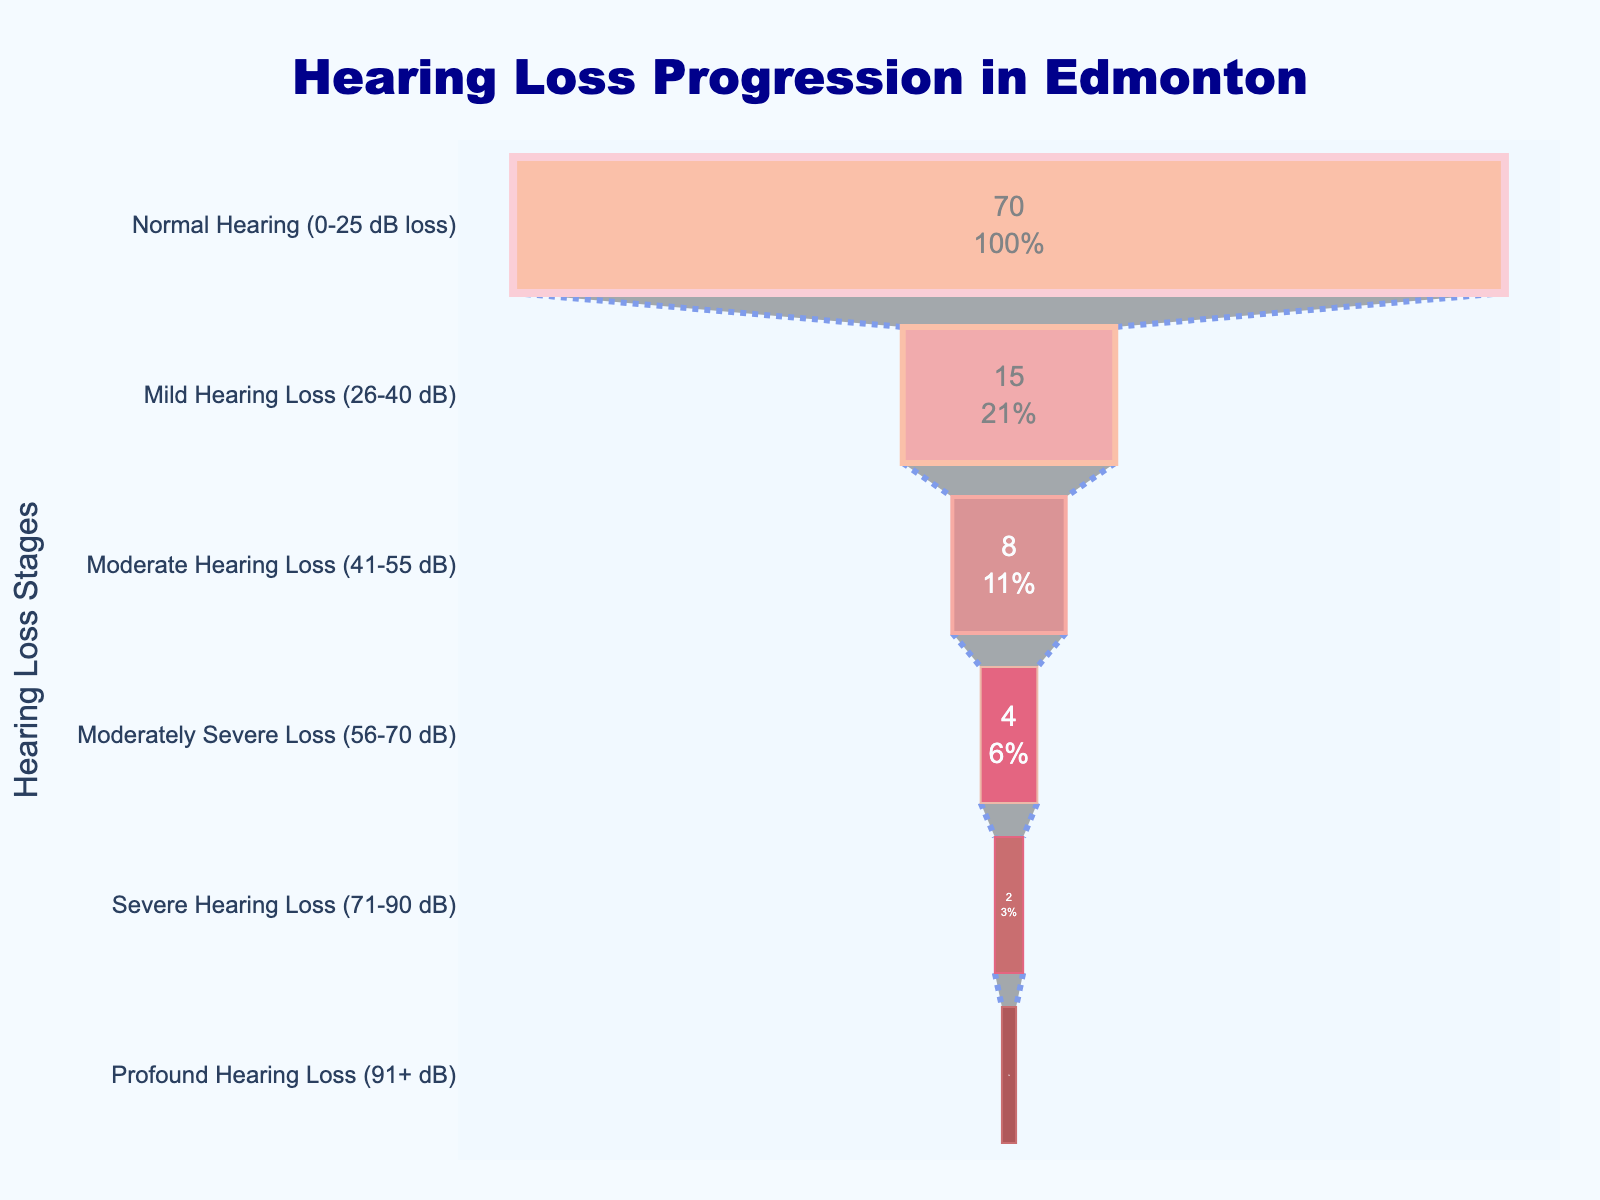what's the title of the chart? The title of the chart is displayed at the top center position of the chart. By reading the title directly from the chart, we find that it is "Hearing Loss Progression in Edmonton".
Answer: Hearing Loss Progression in Edmonton which stage has the highest percentage of affected population? To find the stage with the highest percentage, look at the stages' percentages from the top of the funnel chart. The first stage, "Normal Hearing (0-25 dB loss)", has the highest percentage at 70%.
Answer: Normal Hearing (0-25 dB loss) what is the percentage of population with mild hearing loss? Find the segment labeled "Mild Hearing Loss (26-40 dB)" in the funnel chart and look at the percentage value inside the segment. The value displayed is 15%.
Answer: 15% how many stages are depicted in the funnel chart? Count the number of different stages shown along the y-axis of the funnel chart. There are 6 stages in total.
Answer: 6 compare the percentages of moderate hearing loss and profound hearing loss. which is greater, and by how much? Identify the percentage for "Moderate Hearing Loss (41-55 dB)" which is 8%, and for "Profound Hearing Loss (91+ dB)" which is 1%. Subtract the smaller percentage from the larger one: 8% - 1% = 7%.
Answer: Moderate Hearing Loss by 7% which stages have less than 5% of the affected population? Look for stages with percentage values below 5% in the funnel chart. These stages are "Moderately Severe Loss (56-70 dB)" with 4%, "Severe Hearing Loss (71-90 dB)" with 2%, and "Profound Hearing Loss (91+ dB)" with 1%.
Answer: Moderately Severe Loss, Severe Hearing Loss, Profound Hearing Loss what is the total percentage of the population with more than 40 dB hearing loss? Sum the percentages of stages with more than 40 dB hearing loss: Moderate Hearing Loss (8%), Moderately Severe Loss (4%), Severe Hearing Loss (2%), and Profound Hearing Loss (1%): 8% + 4% + 2% + 1% = 15%.
Answer: 15% is the percentage of population with normal hearing more than double the percentage with mild hearing loss? Compare the percentage of "Normal Hearing (70%)" with double the percentage of "Mild Hearing Loss (2 * 15% = 30%)". Since 70% is greater than 30%, the answer is yes.
Answer: Yes 